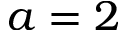Convert formula to latex. <formula><loc_0><loc_0><loc_500><loc_500>a = 2</formula> 